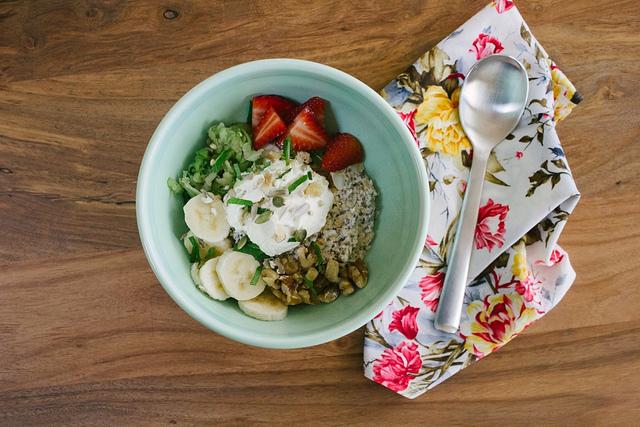What utensil is to the right of the bowl?
Short answer required. Spoon. What kind of napkin is in the table?
Answer briefly. Cloth. What is the bright red fruit?
Write a very short answer. Strawberry. 